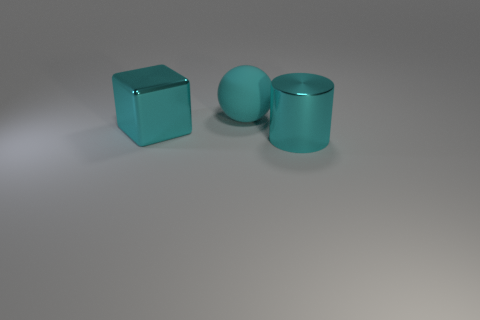Can you describe the texture and material quality of the surface they are resting on? The surface upon which the objects rest displays a matte finish with a subtle grain, which could indicate it is made of a fine material like brushed metal or a treated stone. The muted sheen suggests it's non-reflective, contrasting with the shininess of the cyan objects and thus drawing further visual interest to them. 